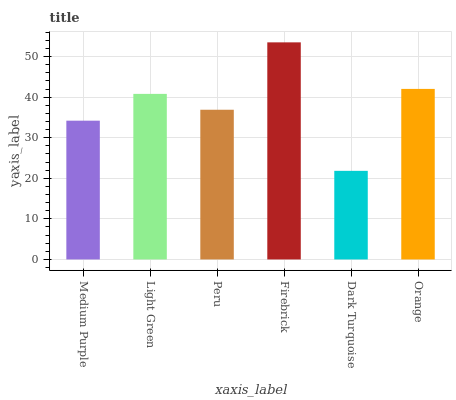Is Dark Turquoise the minimum?
Answer yes or no. Yes. Is Firebrick the maximum?
Answer yes or no. Yes. Is Light Green the minimum?
Answer yes or no. No. Is Light Green the maximum?
Answer yes or no. No. Is Light Green greater than Medium Purple?
Answer yes or no. Yes. Is Medium Purple less than Light Green?
Answer yes or no. Yes. Is Medium Purple greater than Light Green?
Answer yes or no. No. Is Light Green less than Medium Purple?
Answer yes or no. No. Is Light Green the high median?
Answer yes or no. Yes. Is Peru the low median?
Answer yes or no. Yes. Is Dark Turquoise the high median?
Answer yes or no. No. Is Light Green the low median?
Answer yes or no. No. 